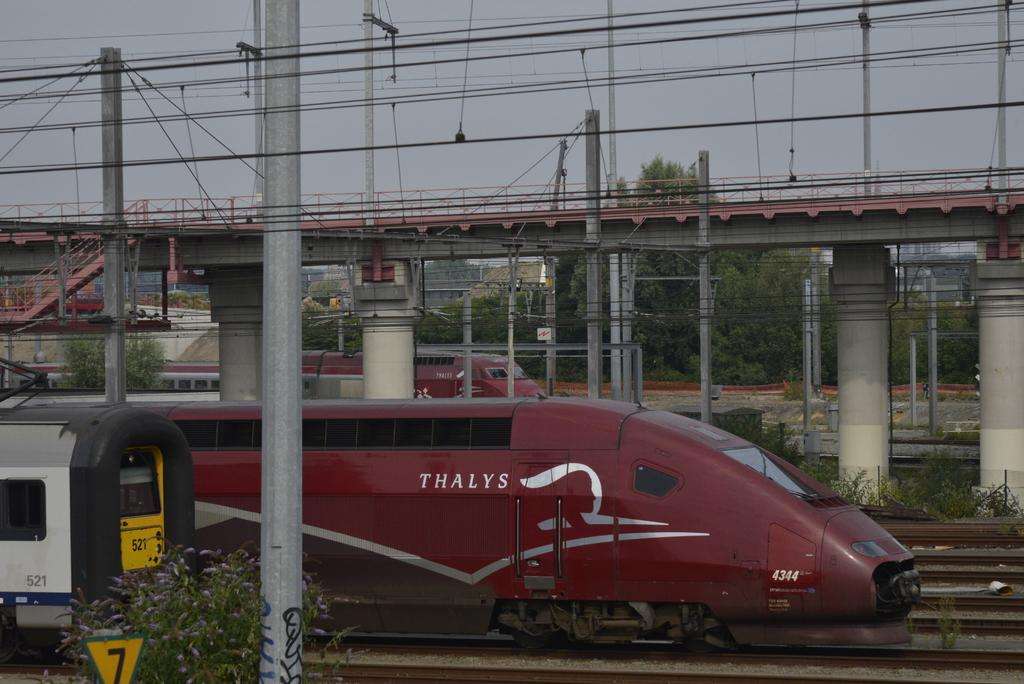<image>
Describe the image concisely. A red train that says Thalys on the side is outdoors. 